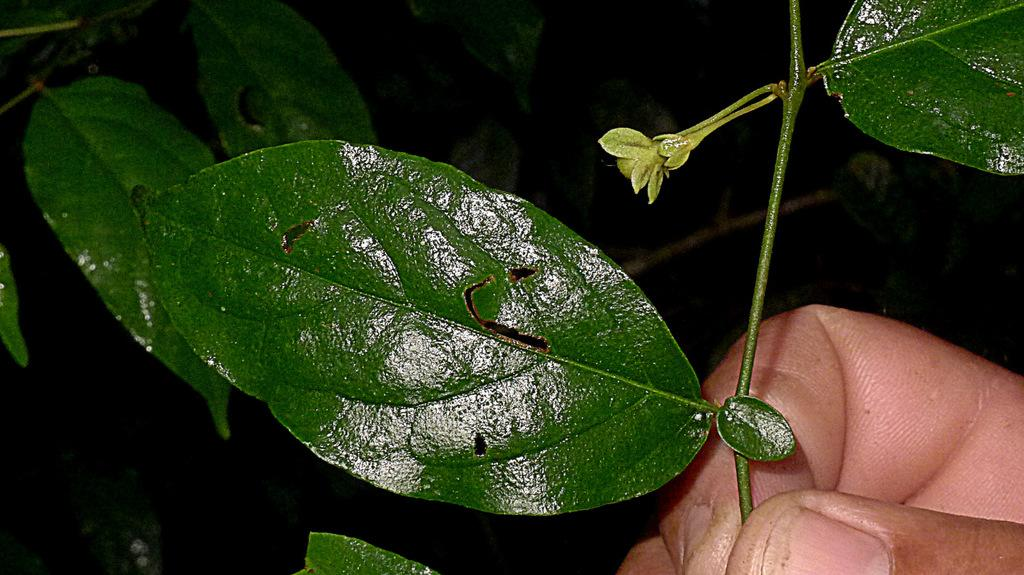What type of natural elements can be seen in the image? There are leaves in the image. Where is the person's hand located in the image? The person's hand is visible at the right bottom of the image. What is the color of the background in the image? The background of the image is dark. How many tails can be seen in the image? There are no tails visible in the image. What type of corn is present in the image? There is no corn present in the image. 